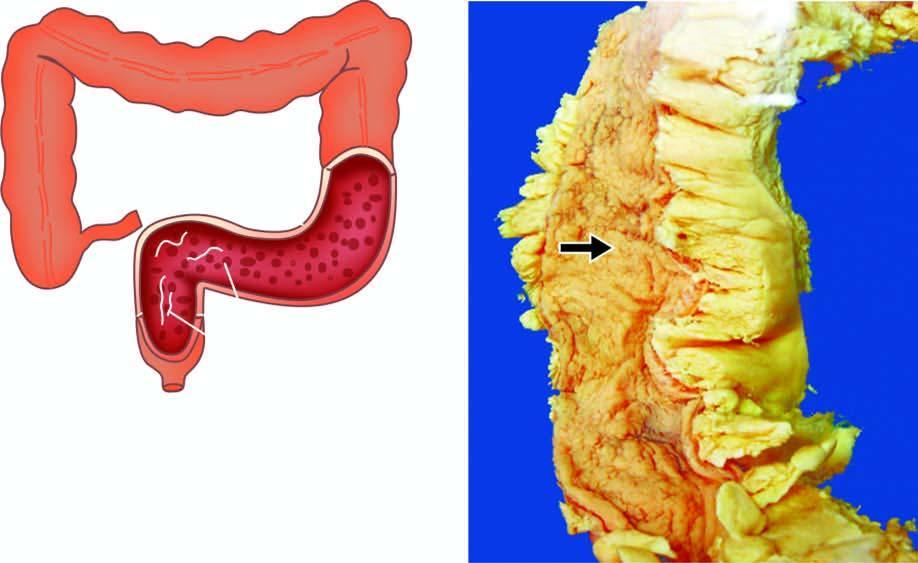re the individual tumour cells superficial with intervening inflammatory pseudopolyps?
Answer the question using a single word or phrase. No 